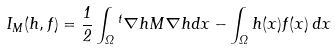<formula> <loc_0><loc_0><loc_500><loc_500>I _ { M } ( h , f ) = \frac { 1 } { 2 } \int _ { \Omega } { ^ { t } \nabla h } M \nabla h d x - \int _ { \Omega } h ( x ) f ( x ) \, d x</formula> 